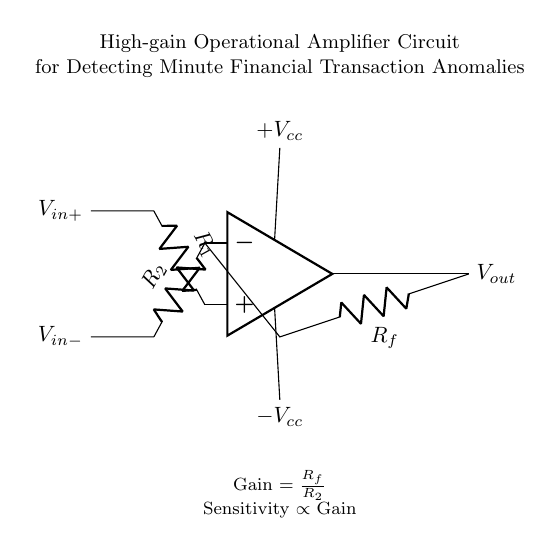What is the input voltage labeled at the non-inverting terminal? The circuit diagram shows the label for the non-inverting terminal as V_in+. This indicates that this is where the positive input voltage is applied.
Answer: V_in+ What is the resistance value associated with the feedback loop? The feedback resistance is labeled as R_f in the circuit, indicating that it is connected in the feedback loop between the output and the inverting input.
Answer: R_f What type of operational amplifier configuration is used? The circuit uses a non-inverting configuration since the input voltage at the non-inverting terminal is fed into the op-amp while the feedback is applied to the inverting terminal.
Answer: Non-inverting How is the gain of the amplifier determined in this circuit? The gain of the amplifier is determined by the formula Gain equals the feedback resistor R_f divided by the resistor R_2 connected to the inverting terminal. This relationship explains how feedback control impacts the amplifier's output.
Answer: Gain = R_f / R_2 What is the significance of the power supply voltages provided? The power supply voltages +V_cc and -V_cc are essential for providing the necessary operating range for the op-amp. The positive and negative voltages ensure proper functioning of the amplifier by allowing it to output a range of voltages based on the input signals.
Answer: +V_cc and -V_cc What can be inferred about sensitivity in this amplifier? The circuit notes that sensitivity is proportional to gain, which implies that as gain increases (i.e., with a larger R_f or smaller R_2), the ability of the amplifier to detect small changes in input signals also increases. This relationship is crucial for detecting minute financial transaction anomalies.
Answer: Sensitivity proportional to Gain 